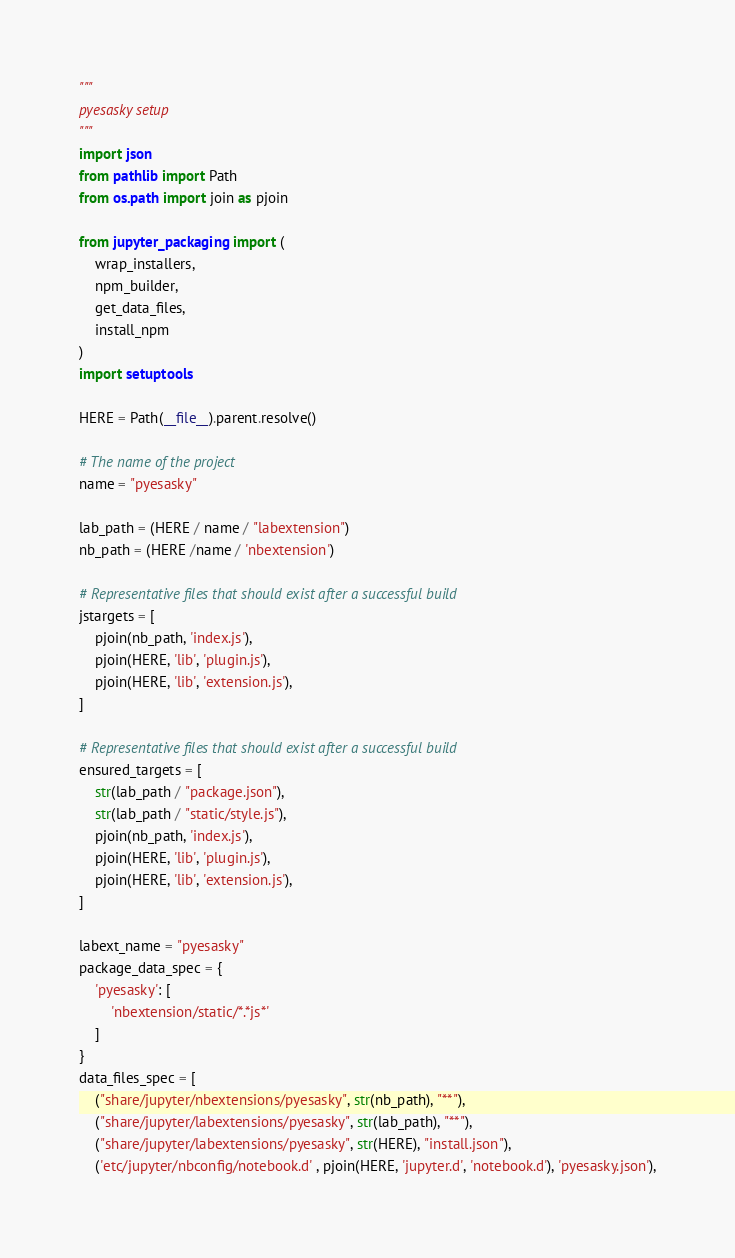<code> <loc_0><loc_0><loc_500><loc_500><_Python_>"""
pyesasky setup
"""
import json
from pathlib import Path
from os.path import join as pjoin 

from jupyter_packaging import (
    wrap_installers,
    npm_builder,
    get_data_files,
    install_npm
)
import setuptools

HERE = Path(__file__).parent.resolve()

# The name of the project
name = "pyesasky"

lab_path = (HERE / name / "labextension")
nb_path = (HERE /name / 'nbextension')

# Representative files that should exist after a successful build
jstargets = [
    pjoin(nb_path, 'index.js'),
    pjoin(HERE, 'lib', 'plugin.js'),
    pjoin(HERE, 'lib', 'extension.js'),
]

# Representative files that should exist after a successful build
ensured_targets = [
    str(lab_path / "package.json"),
    str(lab_path / "static/style.js"),
    pjoin(nb_path, 'index.js'),
    pjoin(HERE, 'lib', 'plugin.js'),
    pjoin(HERE, 'lib', 'extension.js'),
]

labext_name = "pyesasky"
package_data_spec = {
    'pyesasky': [
        'nbextension/static/*.*js*'
    ]
}
data_files_spec = [
    ("share/jupyter/nbextensions/pyesasky", str(nb_path), "**"),
    ("share/jupyter/labextensions/pyesasky", str(lab_path), "**"),
    ("share/jupyter/labextensions/pyesasky", str(HERE), "install.json"),
    ('etc/jupyter/nbconfig/notebook.d' , pjoin(HERE, 'jupyter.d', 'notebook.d'), 'pyesasky.json'),</code> 